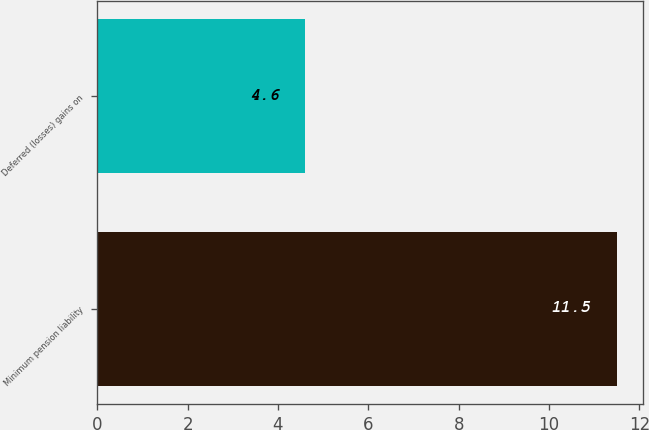<chart> <loc_0><loc_0><loc_500><loc_500><bar_chart><fcel>Minimum pension liability<fcel>Deferred (losses) gains on<nl><fcel>11.5<fcel>4.6<nl></chart> 